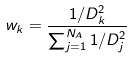<formula> <loc_0><loc_0><loc_500><loc_500>w _ { k } = \frac { 1 / D _ { k } ^ { 2 } } { \sum _ { j = 1 } ^ { N _ { A } } 1 / D _ { j } ^ { 2 } }</formula> 